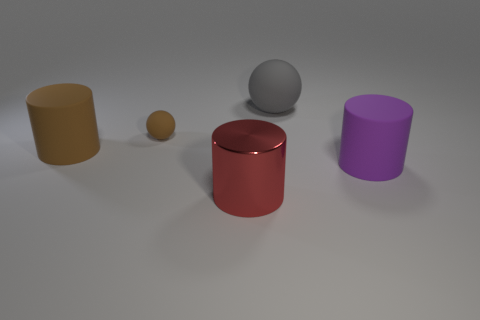Is there a brown metallic object that has the same size as the purple matte cylinder?
Your response must be concise. No. There is a thing that is behind the brown object behind the cylinder that is behind the purple matte cylinder; what is its material?
Your answer should be compact. Rubber. How many big objects are left of the sphere behind the small brown matte sphere?
Offer a terse response. 2. There is a rubber sphere that is left of the red shiny cylinder; does it have the same size as the red shiny thing?
Offer a terse response. No. How many other tiny things are the same shape as the small matte thing?
Ensure brevity in your answer.  0. What shape is the gray thing?
Your response must be concise. Sphere. Are there an equal number of tiny rubber things left of the brown rubber cylinder and big matte blocks?
Provide a succinct answer. Yes. Are there any other things that are the same material as the large red cylinder?
Offer a very short reply. No. Is the large object to the left of the big metallic cylinder made of the same material as the brown sphere?
Ensure brevity in your answer.  Yes. Is the number of large brown rubber cylinders that are on the right side of the big purple cylinder less than the number of big cyan rubber objects?
Ensure brevity in your answer.  No. 